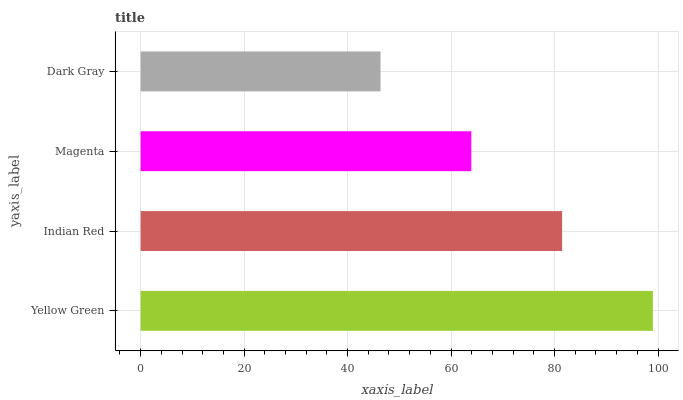Is Dark Gray the minimum?
Answer yes or no. Yes. Is Yellow Green the maximum?
Answer yes or no. Yes. Is Indian Red the minimum?
Answer yes or no. No. Is Indian Red the maximum?
Answer yes or no. No. Is Yellow Green greater than Indian Red?
Answer yes or no. Yes. Is Indian Red less than Yellow Green?
Answer yes or no. Yes. Is Indian Red greater than Yellow Green?
Answer yes or no. No. Is Yellow Green less than Indian Red?
Answer yes or no. No. Is Indian Red the high median?
Answer yes or no. Yes. Is Magenta the low median?
Answer yes or no. Yes. Is Yellow Green the high median?
Answer yes or no. No. Is Indian Red the low median?
Answer yes or no. No. 